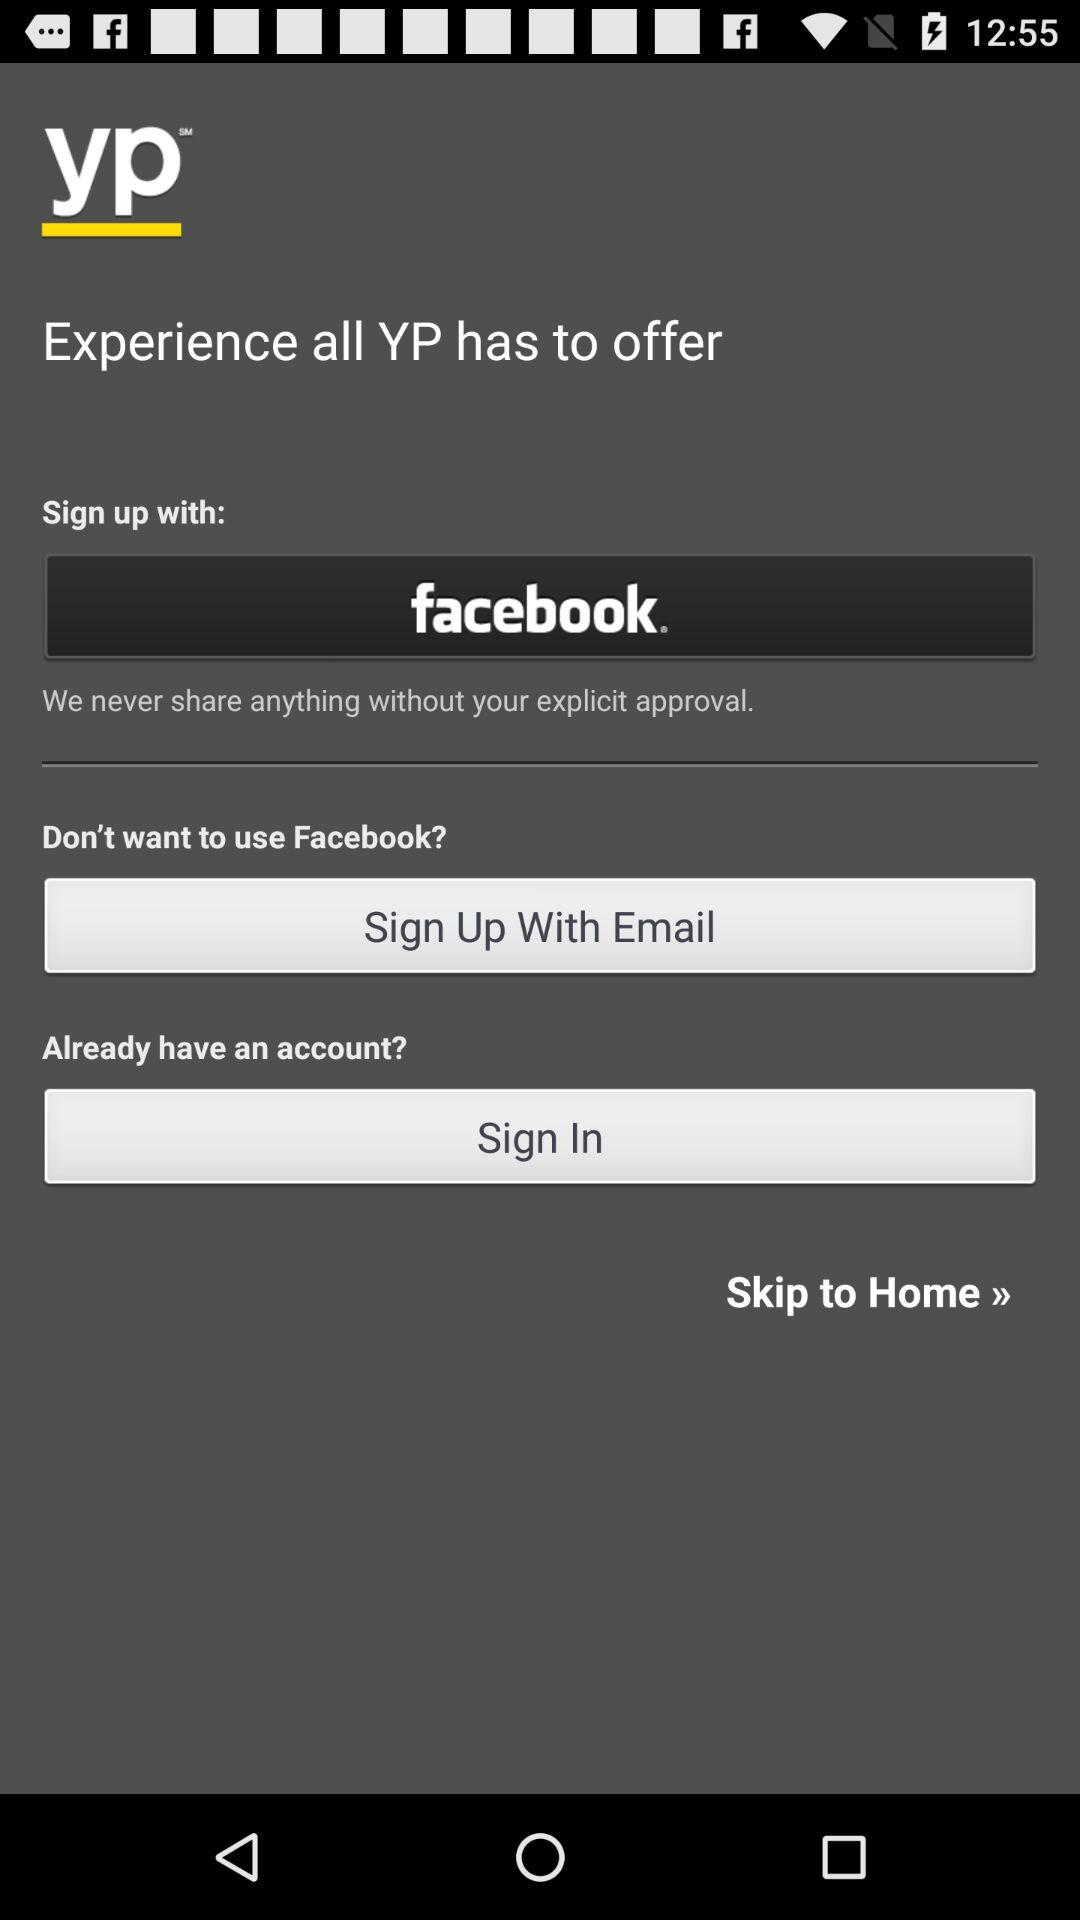What is the application name? The application name is "yp". 